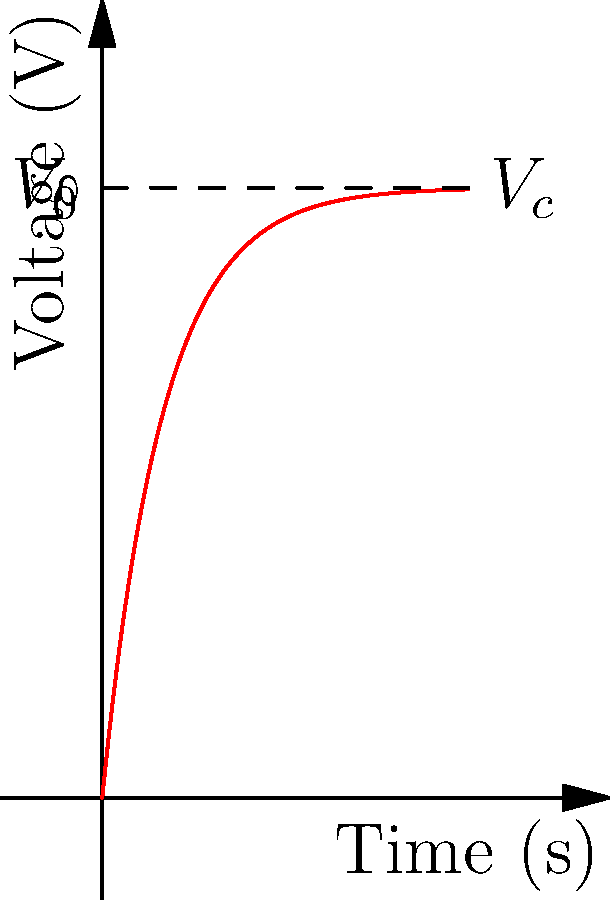As a magazine editor assigning travel articles on technology trends, you're researching RC circuits for a piece on smart home energy systems. The graph shows the voltage across a capacitor in an RC circuit over time. If the initial voltage $V_0$ is 5V and the capacitor reaches 63.2% of its final value at 0.5 seconds, what is the time constant $\tau$ of the circuit? To solve this problem, we'll follow these steps:

1. Recall that the voltage across a capacitor in an RC circuit follows the equation:
   $V_c(t) = V_0(1 - e^{-t/\tau})$

2. We're told that at $t = 0.5$ seconds, the capacitor reaches 63.2% of its final value. This is a key characteristic of RC circuits: at $t = \tau$, the capacitor charges to 63.2% of its final value.

3. Therefore, we can conclude that the time constant $\tau$ is equal to 0.5 seconds.

4. To verify:
   At $t = \tau = 0.5$ seconds:
   $V_c(0.5) = V_0(1 - e^{-0.5/0.5}) = V_0(1 - e^{-1}) = V_0(1 - 0.368) = 0.632V_0$

   This confirms that at $t = 0.5$ seconds, the voltage is 63.2% of the final value.

5. The time constant $\tau$ in an RC circuit is also given by $\tau = RC$, where R is the resistance and C is the capacitance. However, we don't need these individual values to determine $\tau$ from the graph.
Answer: 0.5 seconds 